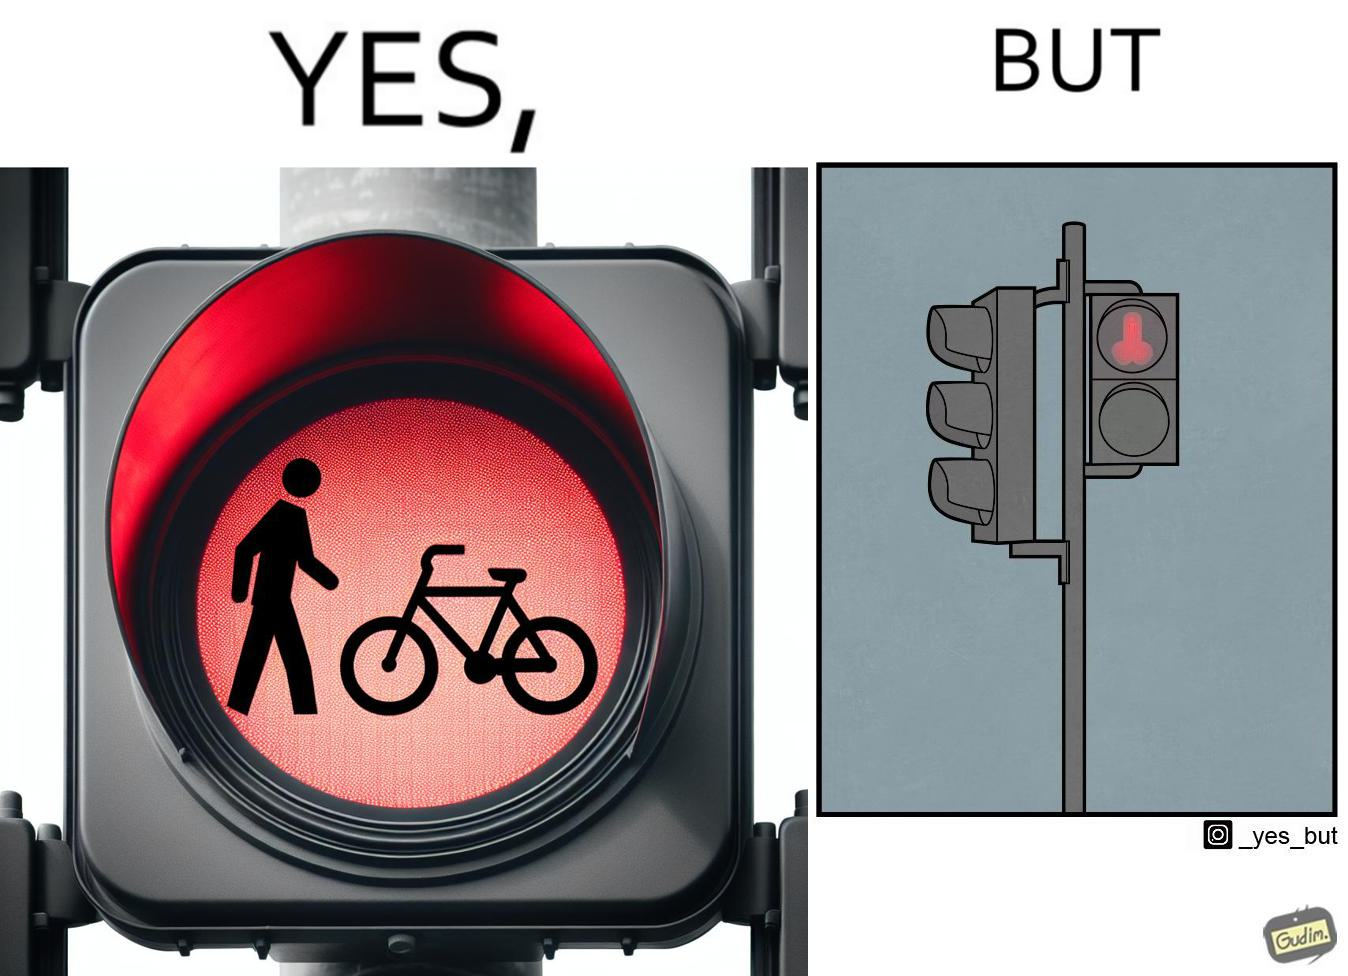Is this a satirical image? Yes, this image is satirical. 